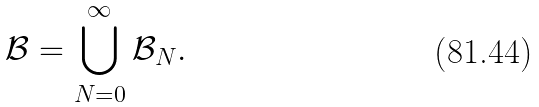Convert formula to latex. <formula><loc_0><loc_0><loc_500><loc_500>\mathcal { B } = \bigcup _ { N = 0 } ^ { \infty } \mathcal { B } _ { N } .</formula> 